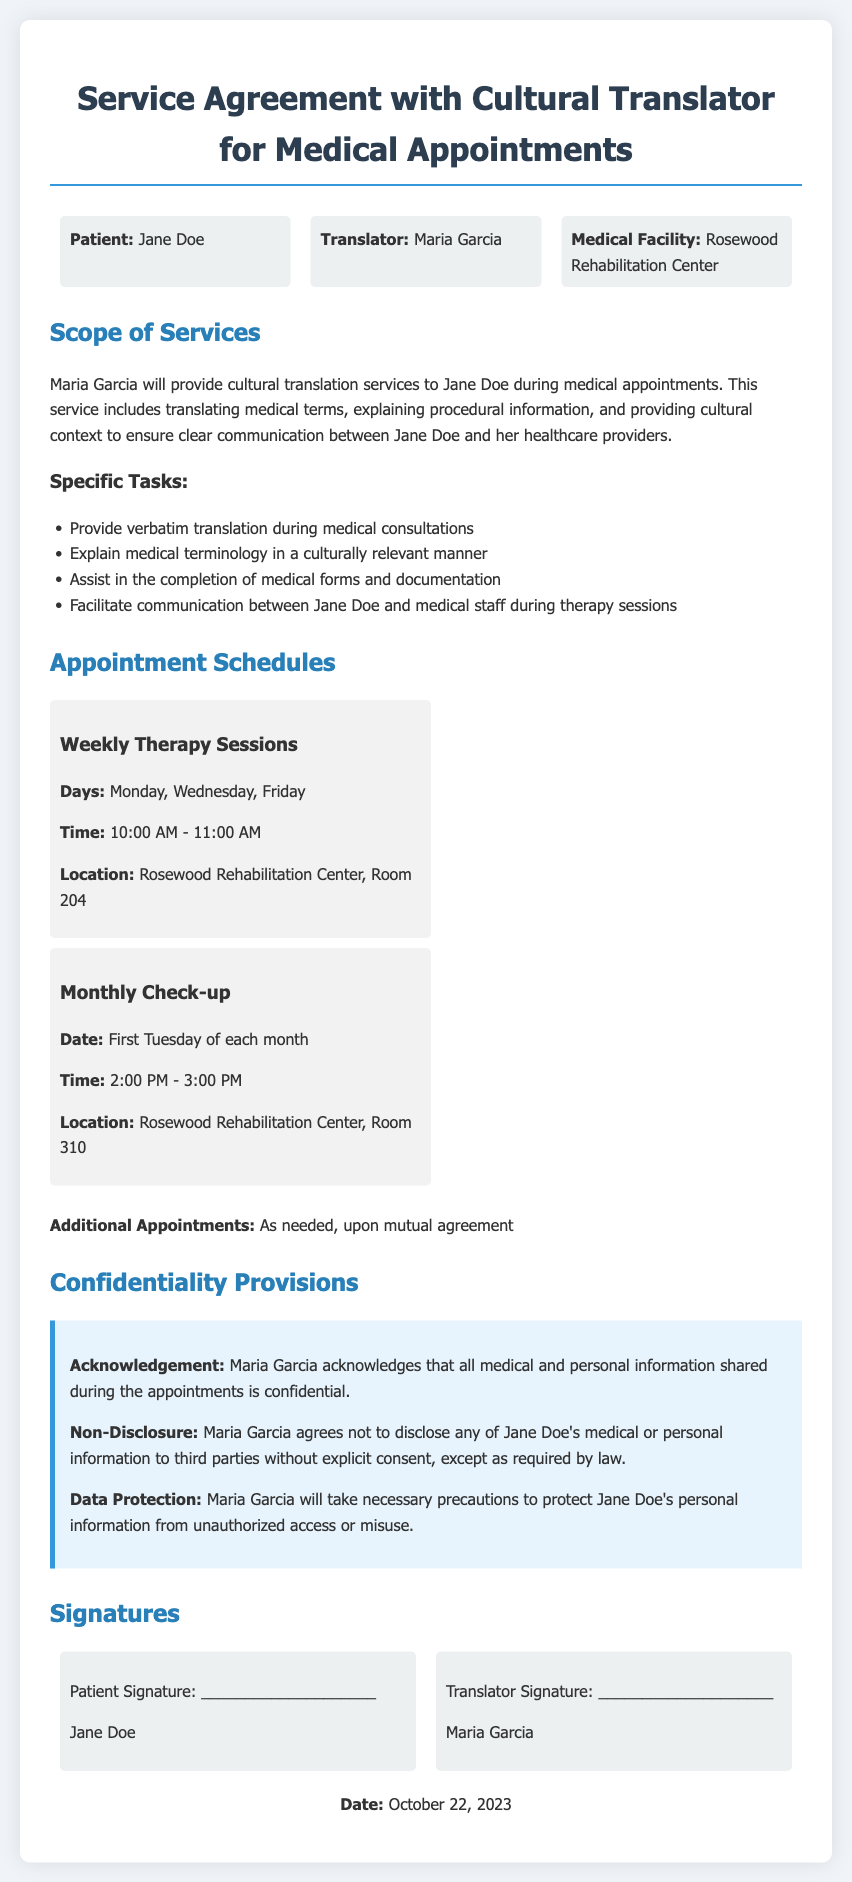What is the name of the patient? The document specifies that the patient's name is Jane Doe.
Answer: Jane Doe Who is the cultural translator? The cultural translator mentioned in the document is Maria Garcia.
Answer: Maria Garcia What is the location for the weekly therapy sessions? The document states that the location for the weekly therapy sessions is Room 204 at the Rosewood Rehabilitation Center.
Answer: Rosewood Rehabilitation Center, Room 204 How often are the monthly check-ups scheduled? The document indicates that monthly check-ups occur once a month, specifically on the first Tuesday of each month.
Answer: Monthly What will the translator provide during medical consultations? The document describes that the translator will provide verbatim translation during medical consultations.
Answer: Verbatim translation What is the time for the monthly check-up? According to the document, the monthly check-up is scheduled from 2:00 PM to 3:00 PM.
Answer: 2:00 PM - 3:00 PM What does Maria Garcia acknowledge regarding information shared? The document states that Maria Garcia acknowledges that all medical and personal information shared during the appointments is confidential.
Answer: Confidential What day of the week are the therapy sessions held? The document mentions that therapy sessions occur on Monday, Wednesday, and Friday.
Answer: Monday, Wednesday, Friday What is required before Maria Garcia can disclose patient's information? The document specifies that Maria Garcia must obtain explicit consent before disclosing any of Jane Doe's information to third parties, except as required by law.
Answer: Explicit consent 